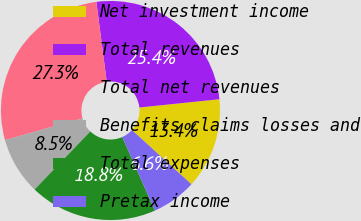Convert chart to OTSL. <chart><loc_0><loc_0><loc_500><loc_500><pie_chart><fcel>Net investment income<fcel>Total revenues<fcel>Total net revenues<fcel>Benefits claims losses and<fcel>Total expenses<fcel>Pretax income<nl><fcel>13.4%<fcel>25.42%<fcel>27.3%<fcel>8.47%<fcel>18.83%<fcel>6.59%<nl></chart> 